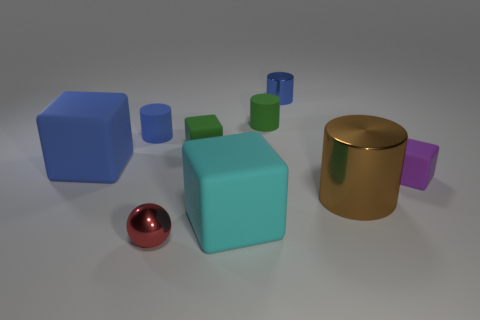How many spheres are either big red shiny things or large things?
Make the answer very short. 0. What number of green matte cylinders are right of the blue cylinder behind the tiny cylinder to the left of the red metallic object?
Make the answer very short. 0. What is the material of the large blue object that is the same shape as the cyan rubber object?
Ensure brevity in your answer.  Rubber. The matte cube to the right of the cyan thing is what color?
Your answer should be compact. Purple. Is the material of the purple object the same as the cylinder that is in front of the big blue rubber object?
Your answer should be compact. No. What is the big cylinder made of?
Provide a short and direct response. Metal. There is a tiny blue object that is the same material as the big brown cylinder; what is its shape?
Make the answer very short. Cylinder. What number of other objects are the same shape as the tiny red object?
Ensure brevity in your answer.  0. There is a cyan block; what number of shiny things are behind it?
Ensure brevity in your answer.  2. There is a blue object that is on the right side of the green matte cube; is it the same size as the matte cylinder that is to the left of the tiny red sphere?
Provide a short and direct response. Yes. 